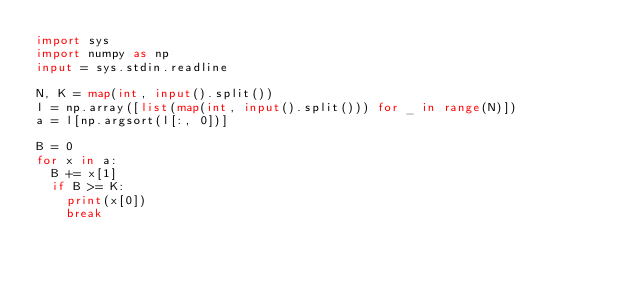Convert code to text. <code><loc_0><loc_0><loc_500><loc_500><_Python_>import sys
import numpy as np
input = sys.stdin.readline

N, K = map(int, input().split())
l = np.array([list(map(int, input().split())) for _ in range(N)])
a = l[np.argsort(l[:, 0])]

B = 0
for x in a:
  B += x[1]
  if B >= K:
    print(x[0])
    break</code> 